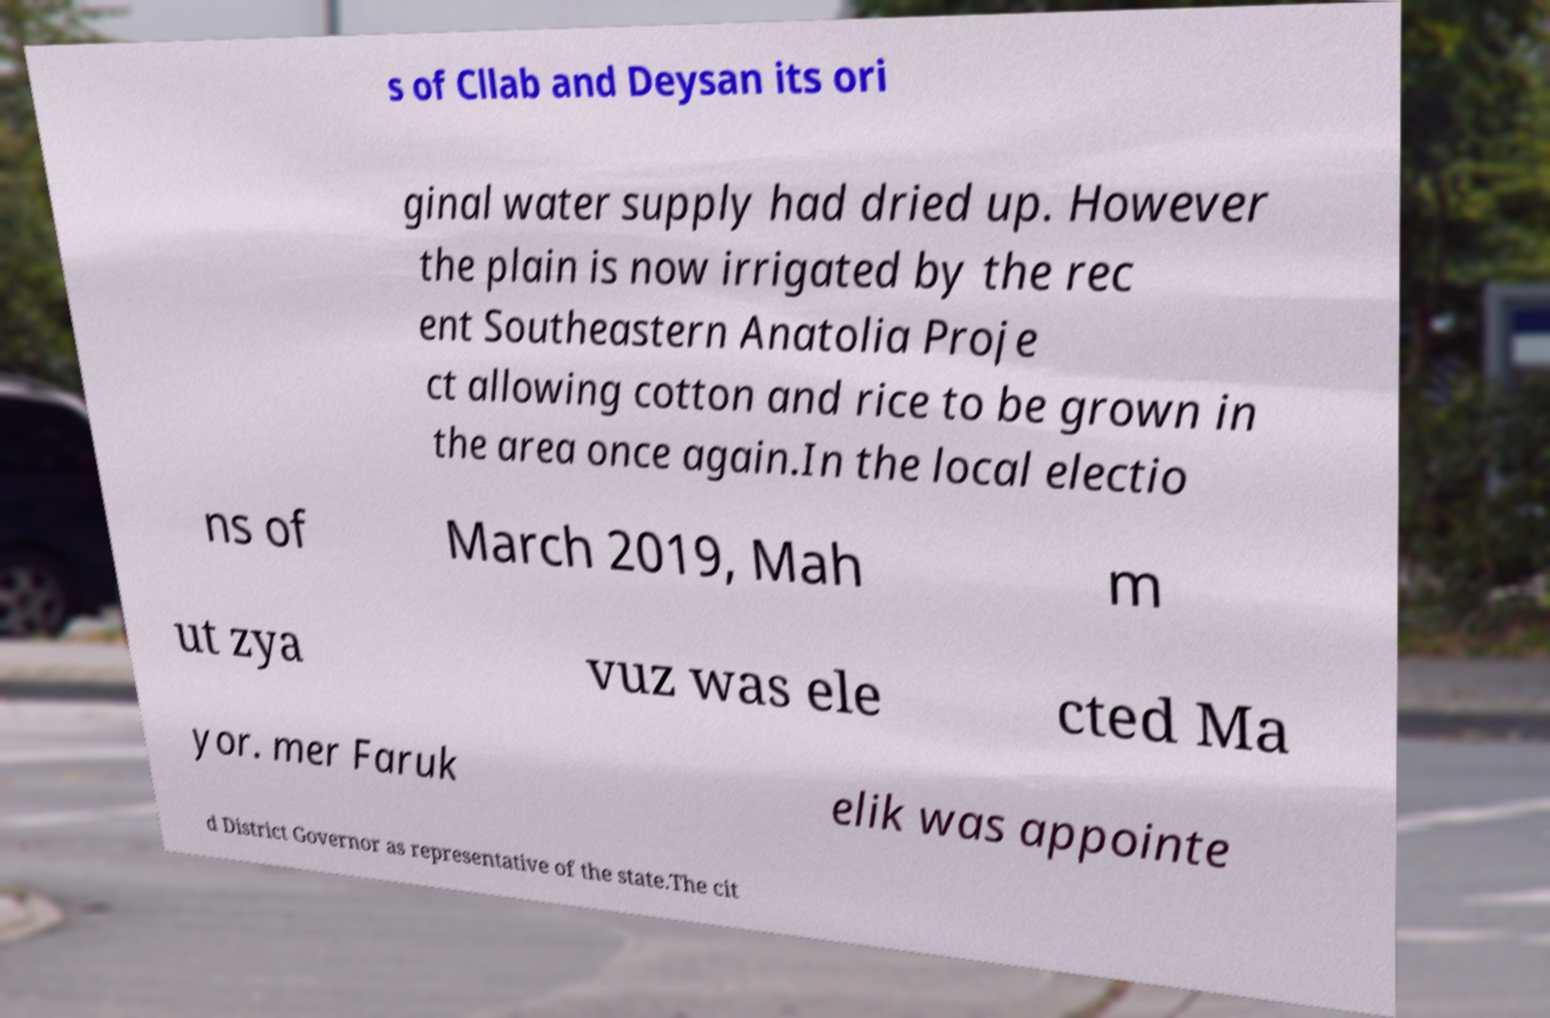Please read and relay the text visible in this image. What does it say? s of Cllab and Deysan its ori ginal water supply had dried up. However the plain is now irrigated by the rec ent Southeastern Anatolia Proje ct allowing cotton and rice to be grown in the area once again.In the local electio ns of March 2019, Mah m ut zya vuz was ele cted Ma yor. mer Faruk elik was appointe d District Governor as representative of the state.The cit 